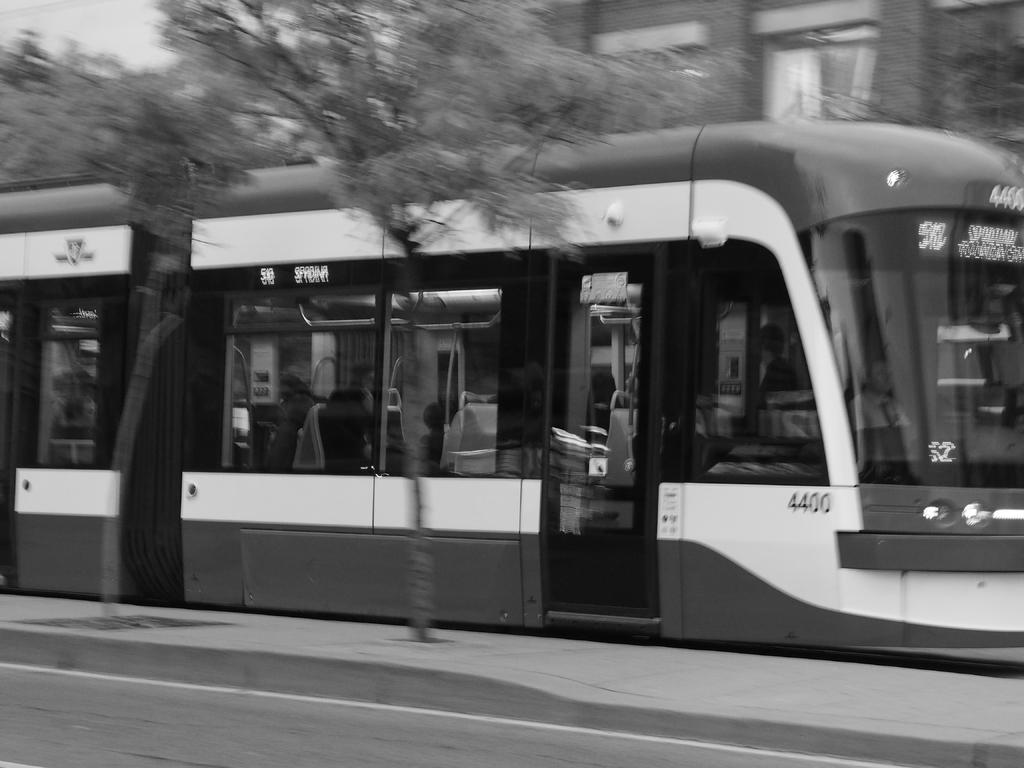What is the color scheme of the image? The image is black and white. What can be seen at the bottom of the image? There is a road at the bottom of the image. What is the main subject in the middle of the image? There is a train in the middle of the image. What structures are visible in the background of the image? There is a building and trees in the background of the image. How many kittens are playing baseball in the image? There are no kittens or baseball activity present in the image. What type of cracker is being used as a prop in the image? There is no cracker present in the image. 